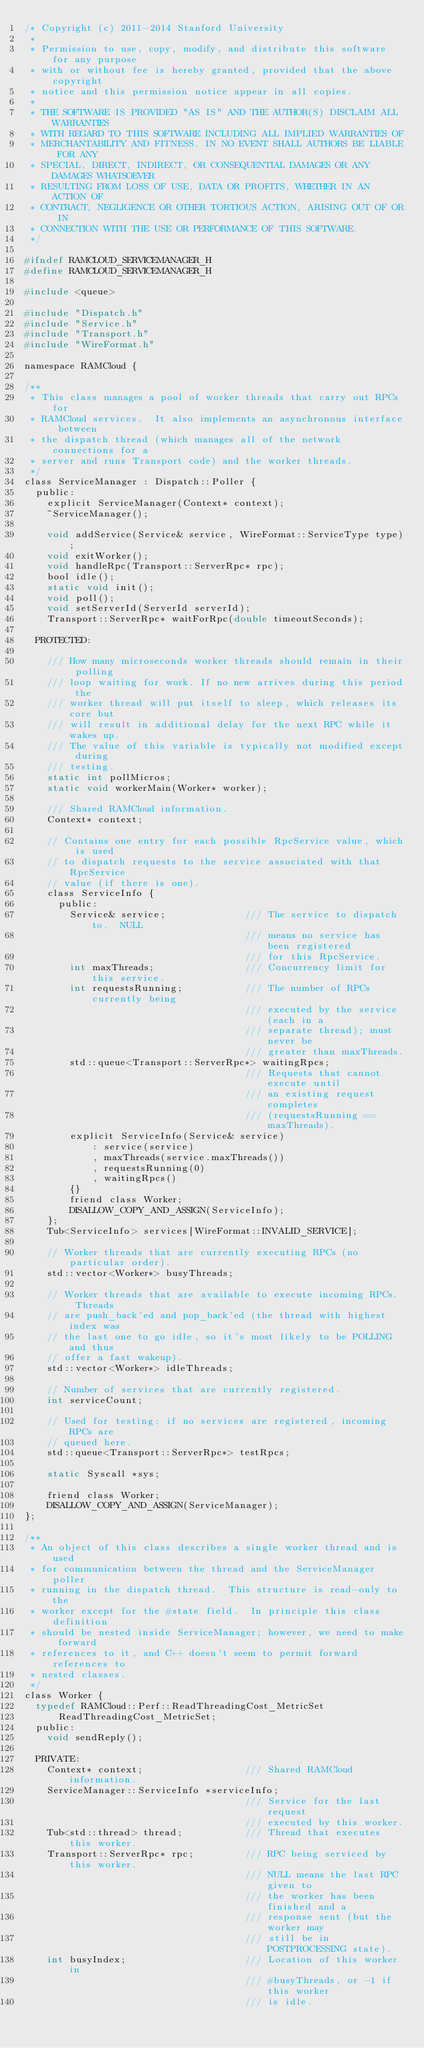Convert code to text. <code><loc_0><loc_0><loc_500><loc_500><_C_>/* Copyright (c) 2011-2014 Stanford University
 *
 * Permission to use, copy, modify, and distribute this software for any purpose
 * with or without fee is hereby granted, provided that the above copyright
 * notice and this permission notice appear in all copies.
 *
 * THE SOFTWARE IS PROVIDED "AS IS" AND THE AUTHOR(S) DISCLAIM ALL WARRANTIES
 * WITH REGARD TO THIS SOFTWARE INCLUDING ALL IMPLIED WARRANTIES OF
 * MERCHANTABILITY AND FITNESS. IN NO EVENT SHALL AUTHORS BE LIABLE FOR ANY
 * SPECIAL, DIRECT, INDIRECT, OR CONSEQUENTIAL DAMAGES OR ANY DAMAGES WHATSOEVER
 * RESULTING FROM LOSS OF USE, DATA OR PROFITS, WHETHER IN AN ACTION OF
 * CONTRACT, NEGLIGENCE OR OTHER TORTIOUS ACTION, ARISING OUT OF OR IN
 * CONNECTION WITH THE USE OR PERFORMANCE OF THIS SOFTWARE.
 */

#ifndef RAMCLOUD_SERVICEMANAGER_H
#define RAMCLOUD_SERVICEMANAGER_H

#include <queue>

#include "Dispatch.h"
#include "Service.h"
#include "Transport.h"
#include "WireFormat.h"

namespace RAMCloud {

/**
 * This class manages a pool of worker threads that carry out RPCs for
 * RAMCloud services.  It also implements an asynchronous interface between
 * the dispatch thread (which manages all of the network connections for a
 * server and runs Transport code) and the worker threads.
 */
class ServiceManager : Dispatch::Poller {
  public:
    explicit ServiceManager(Context* context);
    ~ServiceManager();

    void addService(Service& service, WireFormat::ServiceType type);
    void exitWorker();
    void handleRpc(Transport::ServerRpc* rpc);
    bool idle();
    static void init();
    void poll();
    void setServerId(ServerId serverId);
    Transport::ServerRpc* waitForRpc(double timeoutSeconds);

  PROTECTED:

    /// How many microseconds worker threads should remain in their polling
    /// loop waiting for work. If no new arrives during this period the
    /// worker thread will put itself to sleep, which releases its core but
    /// will result in additional delay for the next RPC while it wakes up.
    /// The value of this variable is typically not modified except during
    /// testing.
    static int pollMicros;
    static void workerMain(Worker* worker);

    /// Shared RAMCloud information.
    Context* context;

    // Contains one entry for each possible RpcService value, which is used
    // to dispatch requests to the service associated with that RpcService
    // value (if there is one).
    class ServiceInfo {
      public:
        Service& service;              /// The service to dispatch to.  NULL
                                       /// means no service has been registered
                                       /// for this RpcService.
        int maxThreads;                /// Concurrency limit for this service.
        int requestsRunning;           /// The number of RPCs currently being
                                       /// executed by the service (each in a
                                       /// separate thread); must never be
                                       /// greater than maxThreads.
        std::queue<Transport::ServerRpc*> waitingRpcs;
                                       /// Requests that cannot execute until
                                       /// an existing request completes
                                       /// (requestsRunning == maxThreads).
        explicit ServiceInfo(Service& service)
            : service(service)
            , maxThreads(service.maxThreads())
            , requestsRunning(0)
            , waitingRpcs()
        {}
        friend class Worker;
        DISALLOW_COPY_AND_ASSIGN(ServiceInfo);
    };
    Tub<ServiceInfo> services[WireFormat::INVALID_SERVICE];

    // Worker threads that are currently executing RPCs (no particular order).
    std::vector<Worker*> busyThreads;

    // Worker threads that are available to execute incoming RPCs.  Threads
    // are push_back'ed and pop_back'ed (the thread with highest index was
    // the last one to go idle, so it's most likely to be POLLING and thus
    // offer a fast wakeup).
    std::vector<Worker*> idleThreads;

    // Number of services that are currently registered.
    int serviceCount;

    // Used for testing: if no services are registered, incoming RPCs are
    // queued here.
    std::queue<Transport::ServerRpc*> testRpcs;

    static Syscall *sys;

    friend class Worker;
    DISALLOW_COPY_AND_ASSIGN(ServiceManager);
};

/**
 * An object of this class describes a single worker thread and is used
 * for communication between the thread and the ServiceManager poller
 * running in the dispatch thread.  This structure is read-only to the
 * worker except for the #state field.  In principle this class definition
 * should be nested inside ServiceManager; however, we need to make forward
 * references to it, and C++ doesn't seem to permit forward references to
 * nested classes.
 */
class Worker {
  typedef RAMCloud::Perf::ReadThreadingCost_MetricSet
      ReadThreadingCost_MetricSet;
  public:
    void sendReply();

  PRIVATE:
    Context* context;                  /// Shared RAMCloud information.
    ServiceManager::ServiceInfo *serviceInfo;
                                       /// Service for the last request
                                       /// executed by this worker.
    Tub<std::thread> thread;           /// Thread that executes this worker.
    Transport::ServerRpc* rpc;         /// RPC being serviced by this worker.
                                       /// NULL means the last RPC given to
                                       /// the worker has been finished and a
                                       /// response sent (but the worker may
                                       /// still be in POSTPROCESSING state).
    int busyIndex;                     /// Location of this worker in
                                       /// #busyThreads, or -1 if this worker
                                       /// is idle.</code> 